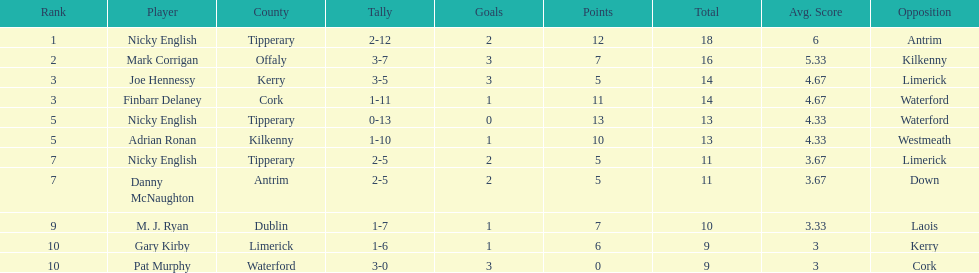If you summed all the totals, what would the figure be? 138. 